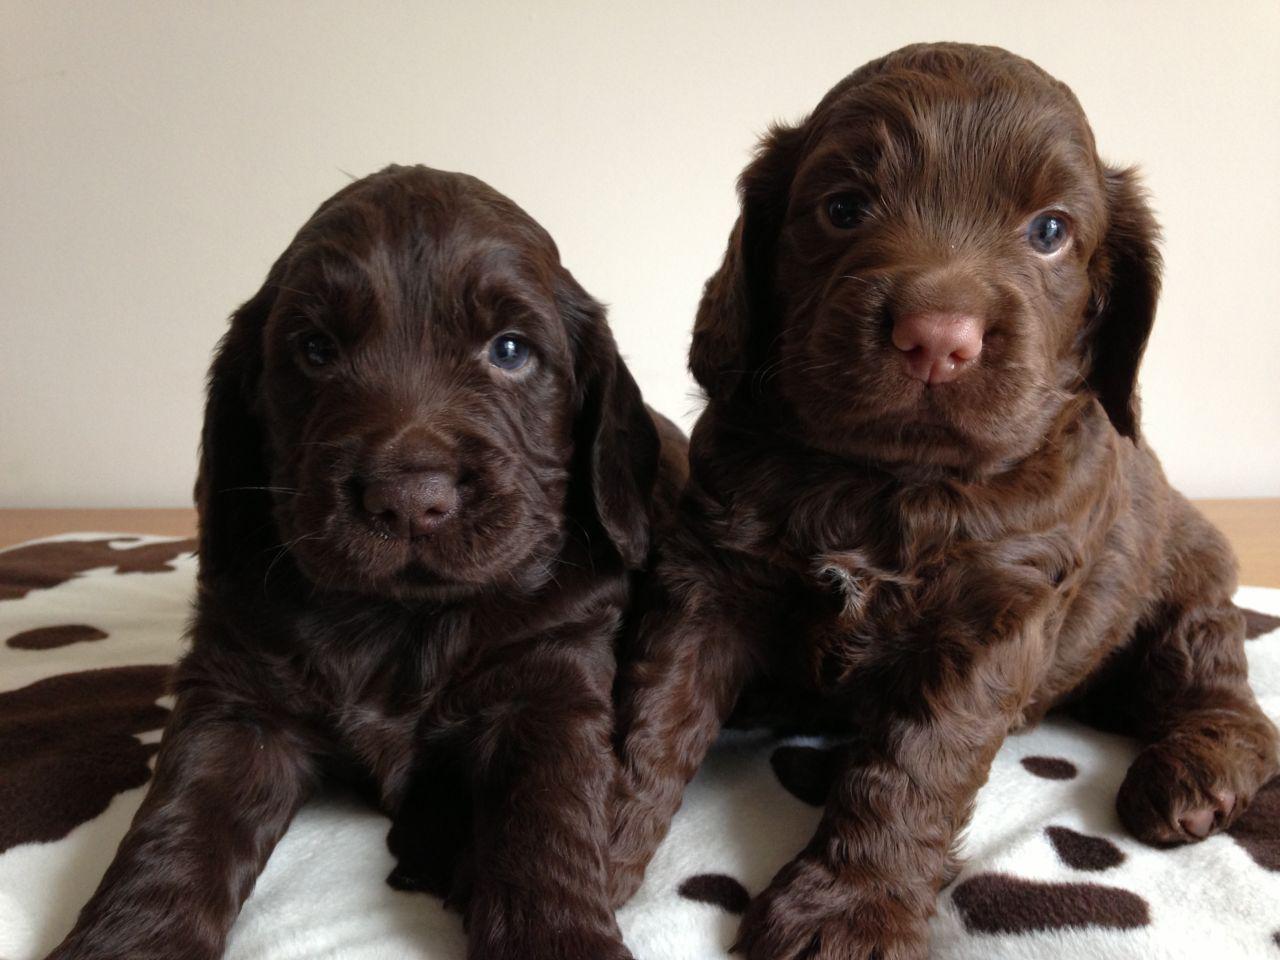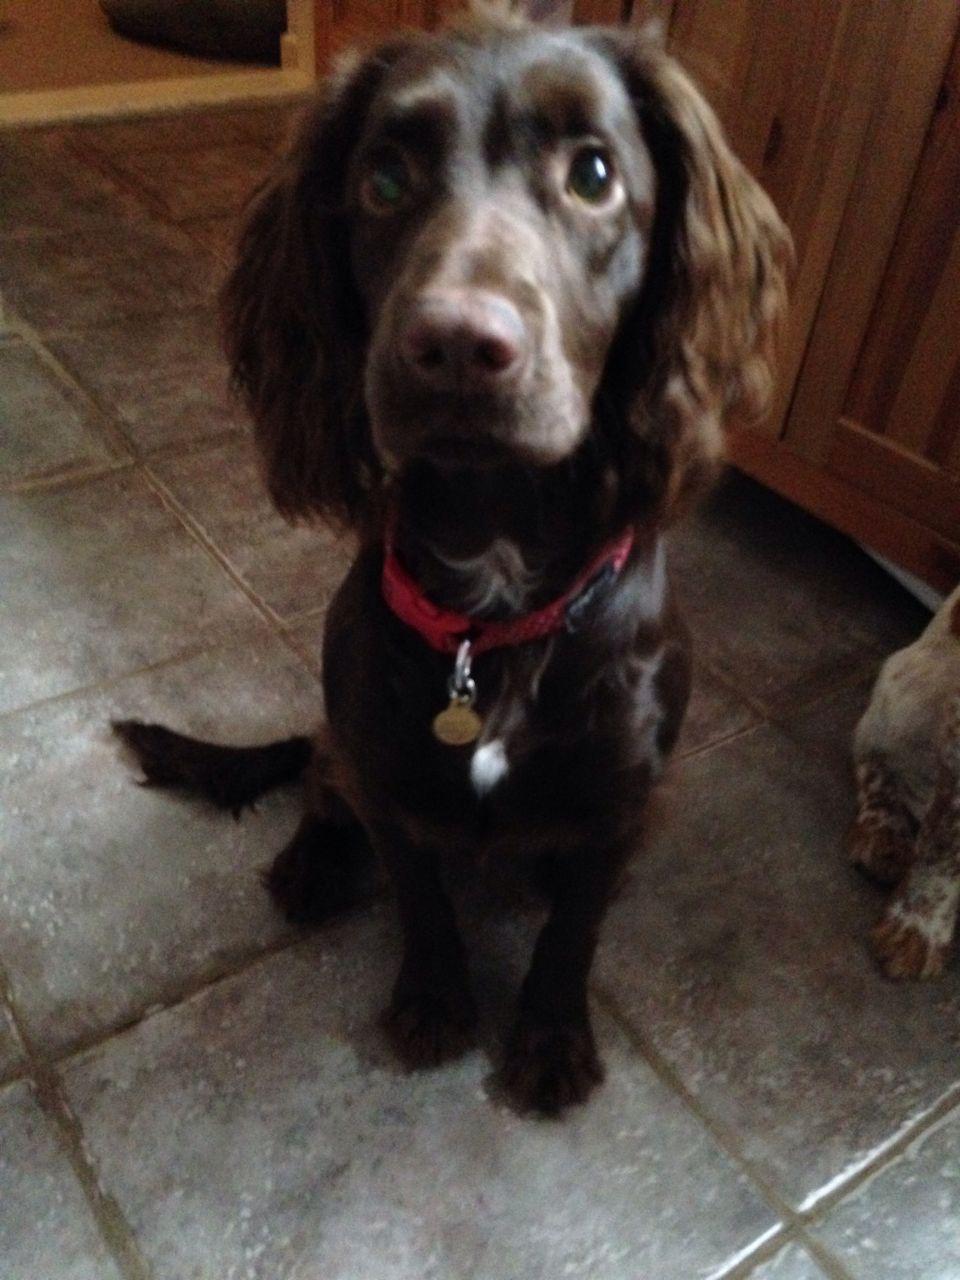The first image is the image on the left, the second image is the image on the right. Assess this claim about the two images: "One dog is brown and white". Correct or not? Answer yes or no. No. The first image is the image on the left, the second image is the image on the right. Assess this claim about the two images: "Each image contains exactly one spaniel, and the dog on the left is younger than the one on the right, which wears a collar but no leash.". Correct or not? Answer yes or no. No. 